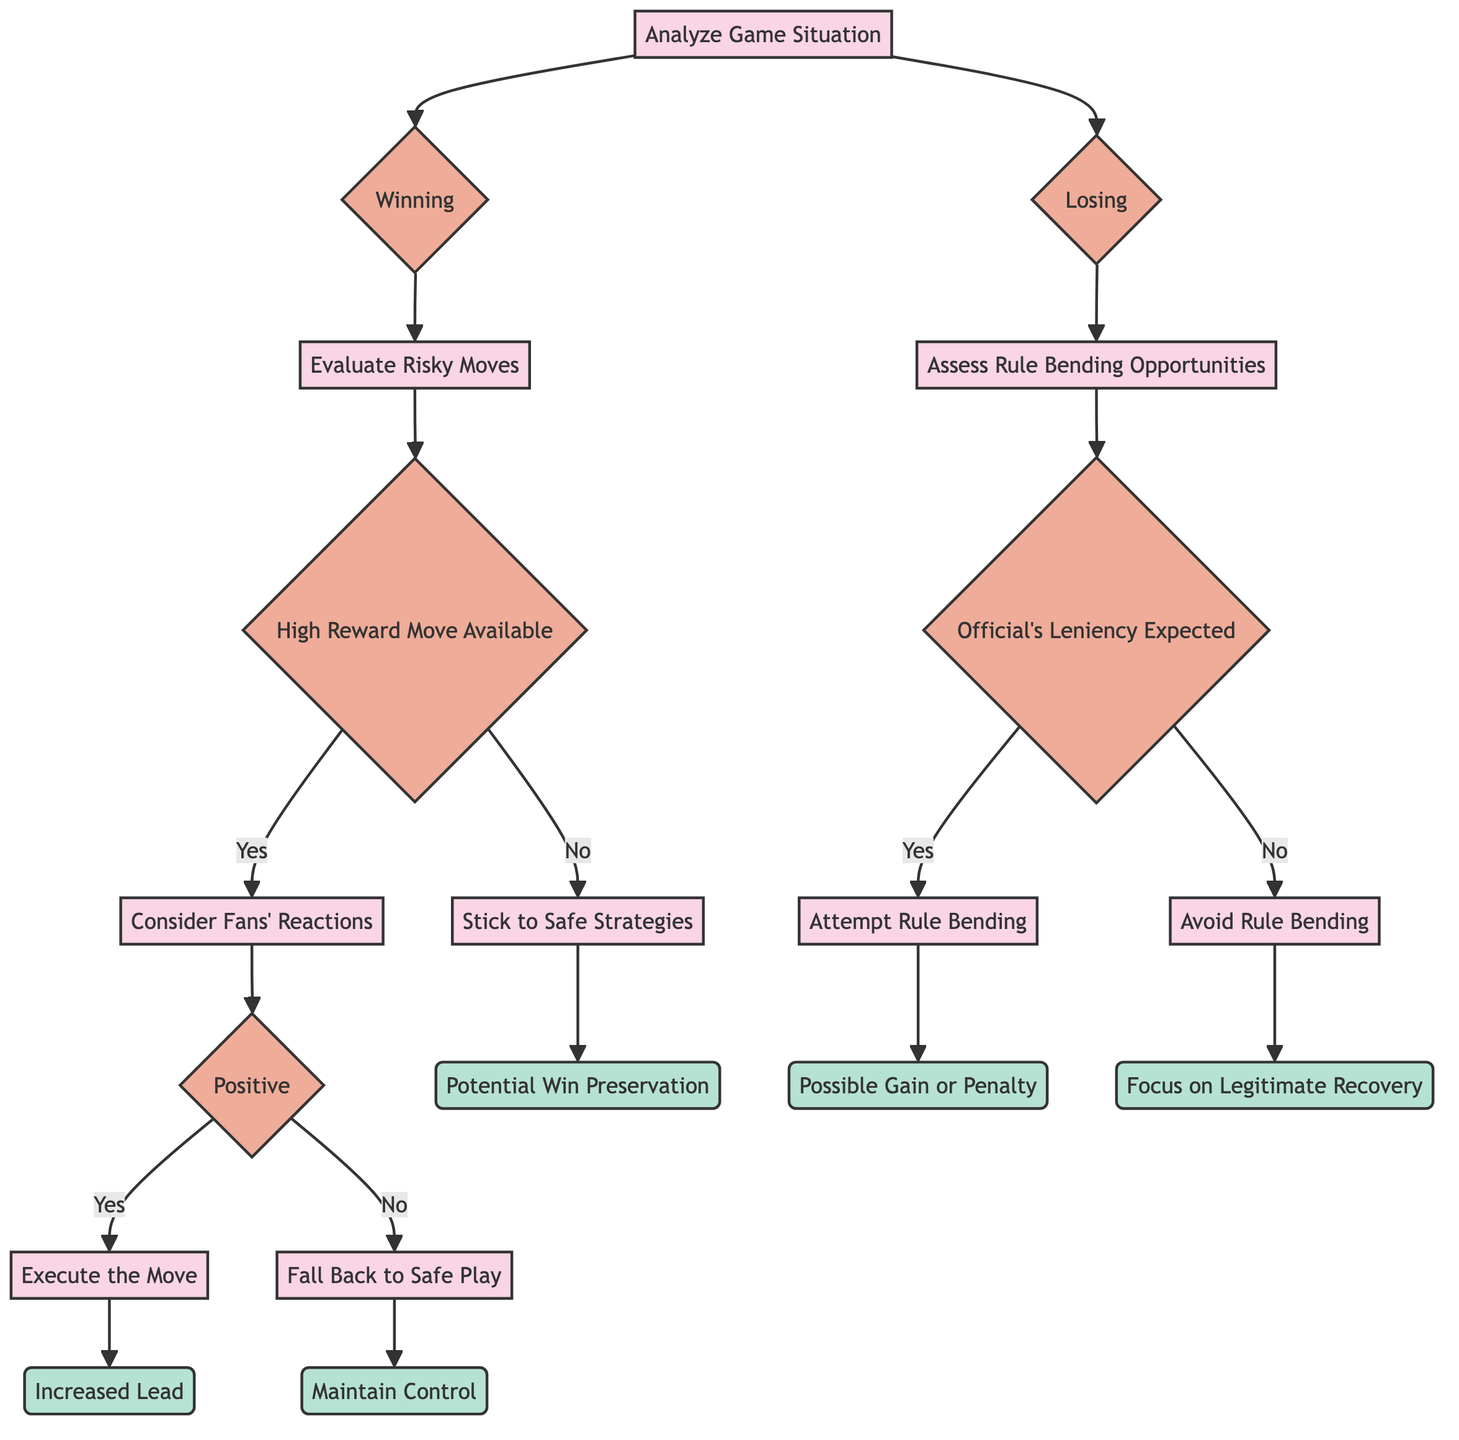What is the first decision in the diagram? The first decision in the diagram is "Analyze Game Situation," which is the root node of the tree from which all paths originate.
Answer: Analyze Game Situation How many outcomes are there for the "Winning" decision path? The "Winning" decision path leads to three outcomes spread across two decisions: "Increased Lead," "Maintain Control," and "Potential Win Preservation." Hence, there are three distinct outcomes related to this path.
Answer: 3 What happens when there is a "Positive" reaction from fans after evaluating a risky move? If there is a "Positive" reaction, the decision branch leads to executing the risky move, resulting in the outcome of an "Increased Lead."
Answer: Increased Lead What should be done if the team is "Losing" and the official is expected to be strict? If the team is "Losing" and the official is strict, the decision is to avoid rule bending, focusing instead on legitimate recovery. This is reflected in the flow of the decision tree as it branches into that specific decision.
Answer: Avoid Rule Bending What is the condition leading to "Stick to Safe Strategies"? The condition leading to "Stick to Safe Strategies" is the absence of a high reward move after evaluating risky moves while winning. This is a direct result of the structure of the decision tree.
Answer: No High Reward Move What are the outcomes associated with "Attempt Rule Bending"? The outcomes associated with "Attempt Rule Bending" are "Possible Gain or Penalty," indicating the uncertain consequences of bending the rules within this scenario.
Answer: Possible Gain or Penalty What decision follows if a "High Reward Move" is not available? If a "High Reward Move" is not available after evaluating risky moves, the decision that follows is to "Stick to Safe Strategies." This means the strategy will aim to preserve the possibility of winning rather than taking risks.
Answer: Stick to Safe Strategies Under what condition would a team decide to "Execute the Move"? A team will decide to "Execute the Move" under the condition where they are winning, a high reward move is available, and fan reactions are positive. This shows the combination of favorable circumstances leading to a proactive decision.
Answer: Positive Fan Reaction What is the outcome of "Fall Back to Safe Play"? If the decision is made to "Fall Back to Safe Play," the outcome is "Maintain Control," which reflects the strategy to secure their position in the game without risk.
Answer: Maintain Control 